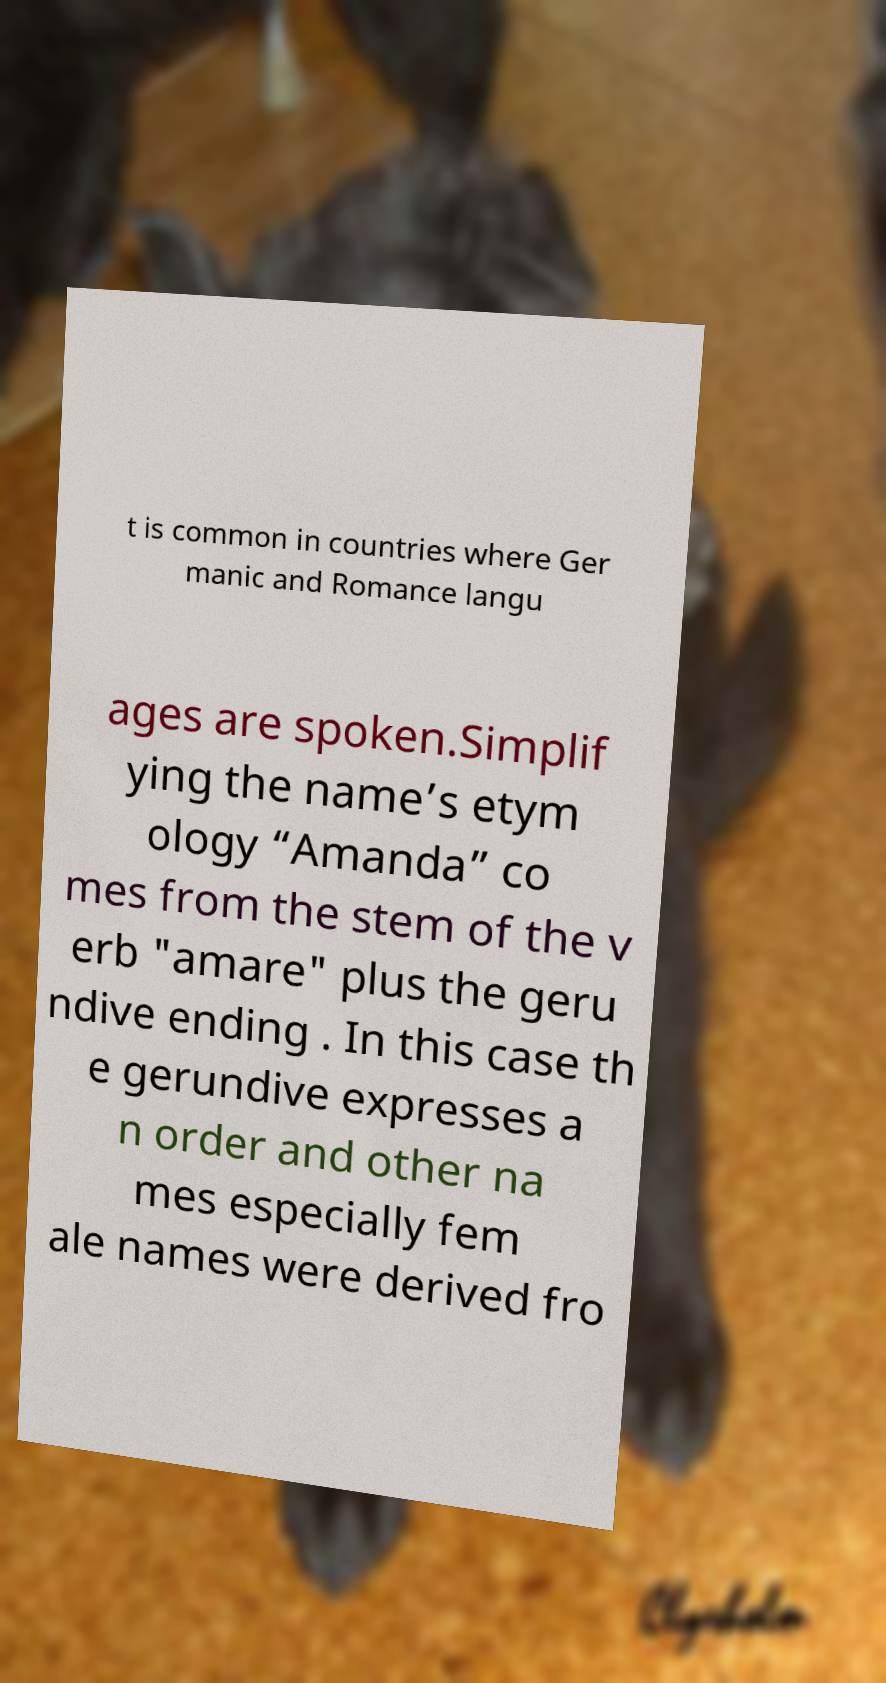Can you accurately transcribe the text from the provided image for me? t is common in countries where Ger manic and Romance langu ages are spoken.Simplif ying the name’s etym ology “Amanda” co mes from the stem of the v erb "amare" plus the geru ndive ending . In this case th e gerundive expresses a n order and other na mes especially fem ale names were derived fro 